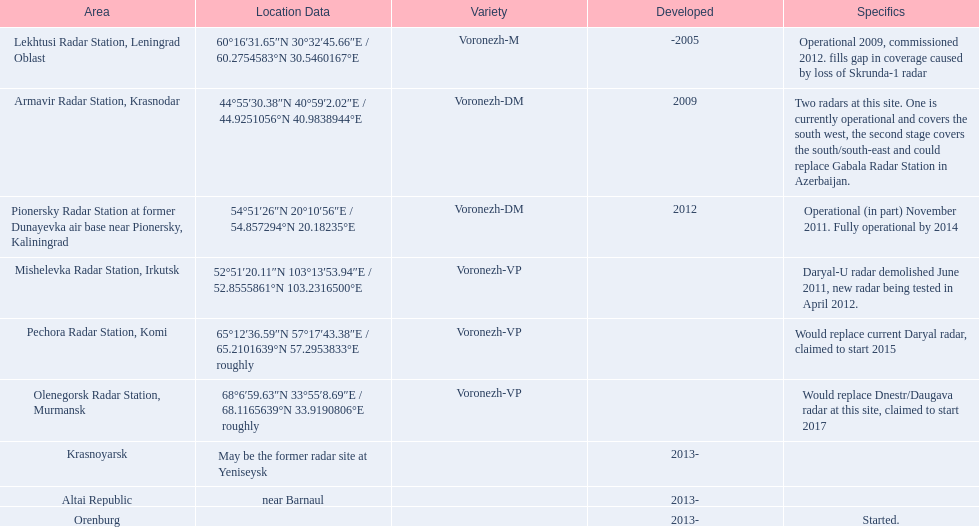Parse the full table in json format. {'header': ['Area', 'Location Data', 'Variety', 'Developed', 'Specifics'], 'rows': [['Lekhtusi Radar Station, Leningrad Oblast', '60°16′31.65″N 30°32′45.66″E\ufeff / \ufeff60.2754583°N 30.5460167°E', 'Voronezh-M', '-2005', 'Operational 2009, commissioned 2012. fills gap in coverage caused by loss of Skrunda-1 radar'], ['Armavir Radar Station, Krasnodar', '44°55′30.38″N 40°59′2.02″E\ufeff / \ufeff44.9251056°N 40.9838944°E', 'Voronezh-DM', '2009', 'Two radars at this site. One is currently operational and covers the south west, the second stage covers the south/south-east and could replace Gabala Radar Station in Azerbaijan.'], ['Pionersky Radar Station at former Dunayevka air base near Pionersky, Kaliningrad', '54°51′26″N 20°10′56″E\ufeff / \ufeff54.857294°N 20.18235°E', 'Voronezh-DM', '2012', 'Operational (in part) November 2011. Fully operational by 2014'], ['Mishelevka Radar Station, Irkutsk', '52°51′20.11″N 103°13′53.94″E\ufeff / \ufeff52.8555861°N 103.2316500°E', 'Voronezh-VP', '', 'Daryal-U radar demolished June 2011, new radar being tested in April 2012.'], ['Pechora Radar Station, Komi', '65°12′36.59″N 57°17′43.38″E\ufeff / \ufeff65.2101639°N 57.2953833°E roughly', 'Voronezh-VP', '', 'Would replace current Daryal radar, claimed to start 2015'], ['Olenegorsk Radar Station, Murmansk', '68°6′59.63″N 33°55′8.69″E\ufeff / \ufeff68.1165639°N 33.9190806°E roughly', 'Voronezh-VP', '', 'Would replace Dnestr/Daugava radar at this site, claimed to start 2017'], ['Krasnoyarsk', 'May be the former radar site at Yeniseysk', '', '2013-', ''], ['Altai Republic', 'near Barnaul', '', '2013-', ''], ['Orenburg', '', '', '2013-', 'Started.']]} Where is each radar? Lekhtusi Radar Station, Leningrad Oblast, Armavir Radar Station, Krasnodar, Pionersky Radar Station at former Dunayevka air base near Pionersky, Kaliningrad, Mishelevka Radar Station, Irkutsk, Pechora Radar Station, Komi, Olenegorsk Radar Station, Murmansk, Krasnoyarsk, Altai Republic, Orenburg. What are the details of each radar? Operational 2009, commissioned 2012. fills gap in coverage caused by loss of Skrunda-1 radar, Two radars at this site. One is currently operational and covers the south west, the second stage covers the south/south-east and could replace Gabala Radar Station in Azerbaijan., Operational (in part) November 2011. Fully operational by 2014, Daryal-U radar demolished June 2011, new radar being tested in April 2012., Would replace current Daryal radar, claimed to start 2015, Would replace Dnestr/Daugava radar at this site, claimed to start 2017, , , Started. Which radar is detailed to start in 2015? Pechora Radar Station, Komi. 